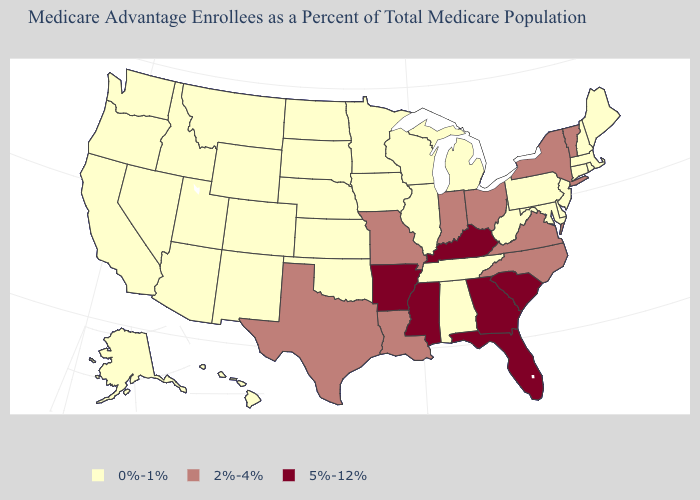Does New York have the same value as Ohio?
Give a very brief answer. Yes. Name the states that have a value in the range 0%-1%?
Concise answer only. Alaska, Alabama, Arizona, California, Colorado, Connecticut, Delaware, Hawaii, Iowa, Idaho, Illinois, Kansas, Massachusetts, Maryland, Maine, Michigan, Minnesota, Montana, North Dakota, Nebraska, New Hampshire, New Jersey, New Mexico, Nevada, Oklahoma, Oregon, Pennsylvania, Rhode Island, South Dakota, Tennessee, Utah, Washington, Wisconsin, West Virginia, Wyoming. What is the value of Missouri?
Write a very short answer. 2%-4%. What is the lowest value in the USA?
Short answer required. 0%-1%. What is the value of Missouri?
Short answer required. 2%-4%. Which states have the highest value in the USA?
Write a very short answer. Arkansas, Florida, Georgia, Kentucky, Mississippi, South Carolina. What is the lowest value in states that border Louisiana?
Give a very brief answer. 2%-4%. What is the value of New York?
Short answer required. 2%-4%. What is the value of New Hampshire?
Write a very short answer. 0%-1%. Does Washington have a lower value than Virginia?
Concise answer only. Yes. What is the value of North Carolina?
Concise answer only. 2%-4%. How many symbols are there in the legend?
Answer briefly. 3. What is the value of Colorado?
Concise answer only. 0%-1%. Does the map have missing data?
Answer briefly. No. What is the highest value in states that border West Virginia?
Give a very brief answer. 5%-12%. 